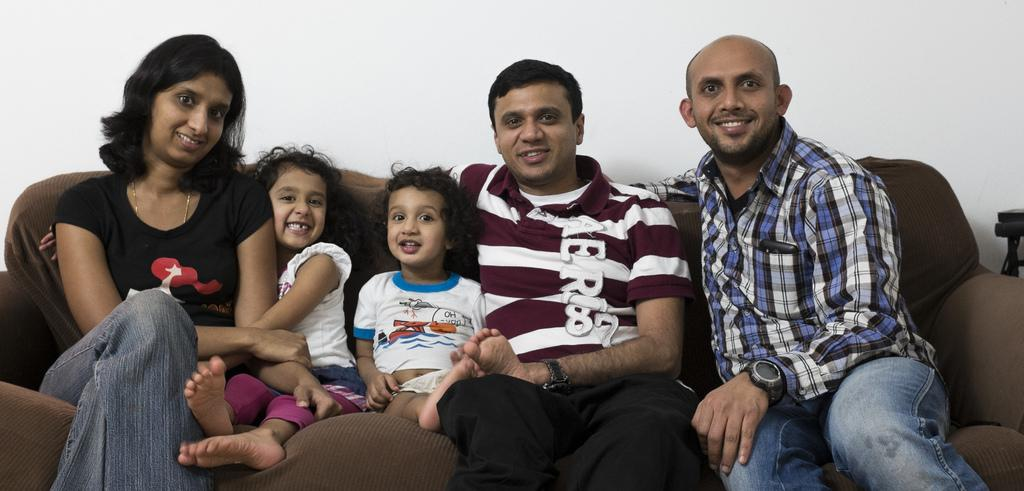What is the main object in the center of the image? There is a couch in the center of the image. How many people are sitting on the couch? There are three persons sitting on the couch. How many of them are children? There are two children sitting on the couch. What is the facial expression of the persons and children? The persons and children are smiling. What can be seen in the background of the image? There is a wall in the background of the image. What type of dinner is being served on the couch in the image? There is no dinner visible in the image; it only shows three persons and two children sitting on a couch. Can you see a sweater on any of the persons in the image? There is no sweater mentioned or visible on any of the persons in the image. 